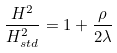Convert formula to latex. <formula><loc_0><loc_0><loc_500><loc_500>\frac { H ^ { 2 } } { H ^ { 2 } _ { s t d } } = 1 + \frac { \rho } { 2 \lambda }</formula> 